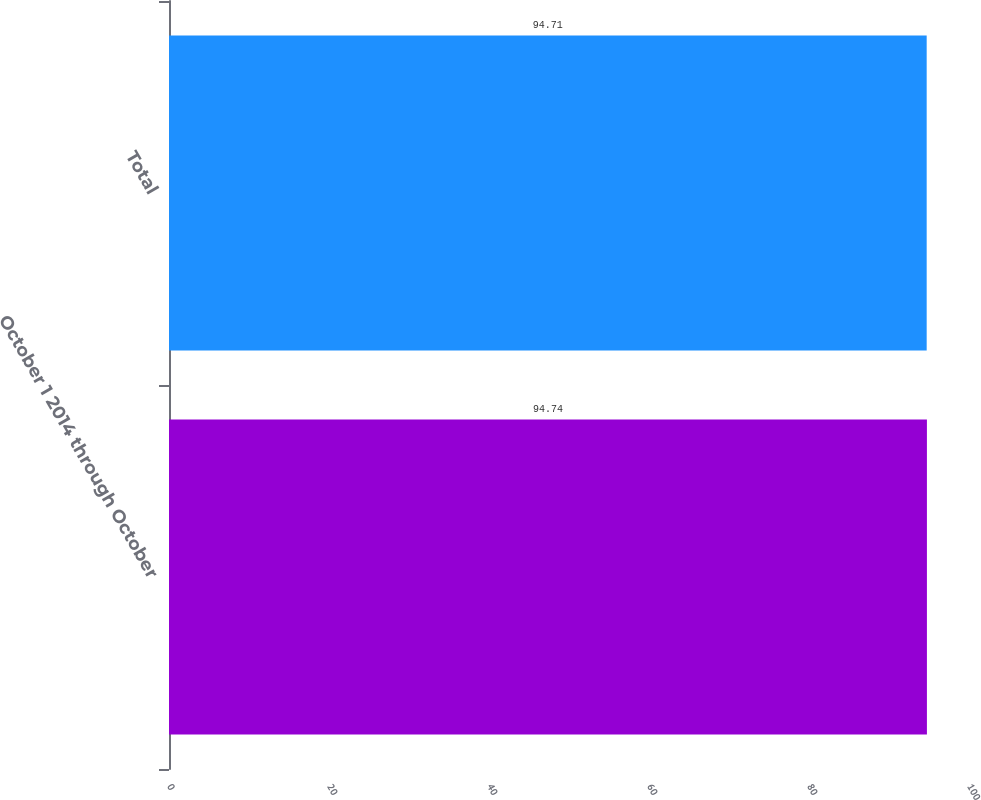Convert chart. <chart><loc_0><loc_0><loc_500><loc_500><bar_chart><fcel>October 1 2014 through October<fcel>Total<nl><fcel>94.74<fcel>94.71<nl></chart> 